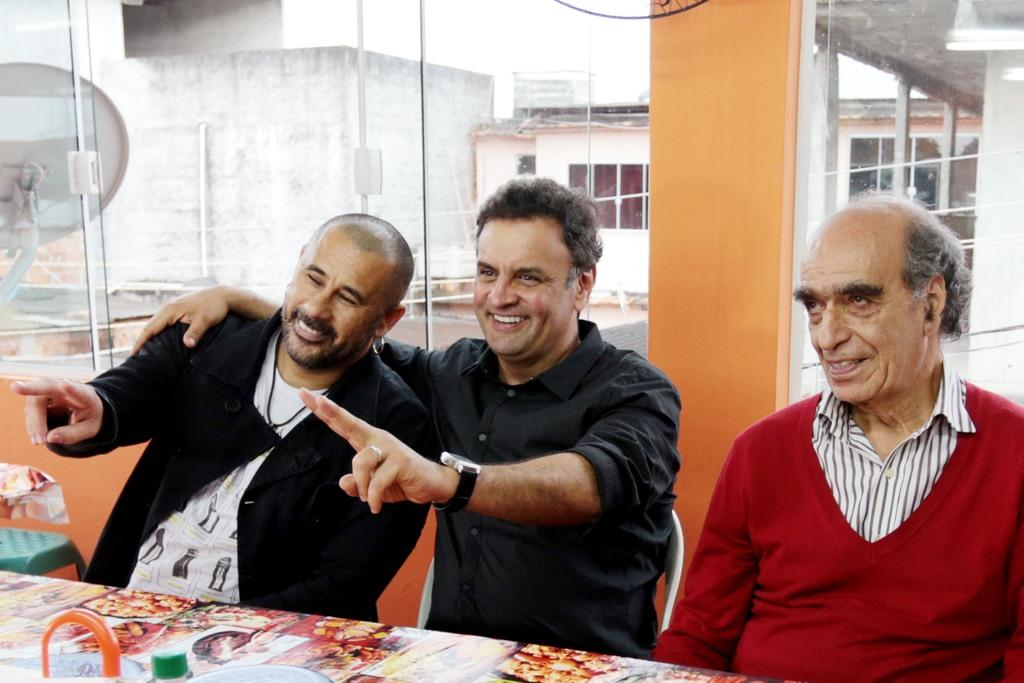What is the main subject of the picture? The main subject of the picture is a dog. What is the dog doing in the picture? The dog is playing with a ball in the picture. Where is the dog located in the image? The dog is in the grass in the image. What can be seen in the background of the picture? There is a fence and a house in the background of the picture. What type of card is the dog holding in the image? There is no card present in the image; the dog is playing with a ball. What color is the ink used to draw the dog in the image? The image is not a drawing, and there is no ink used; it is a photograph of a real dog. 